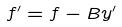Convert formula to latex. <formula><loc_0><loc_0><loc_500><loc_500>f ^ { \prime } = f - B y ^ { \prime }</formula> 